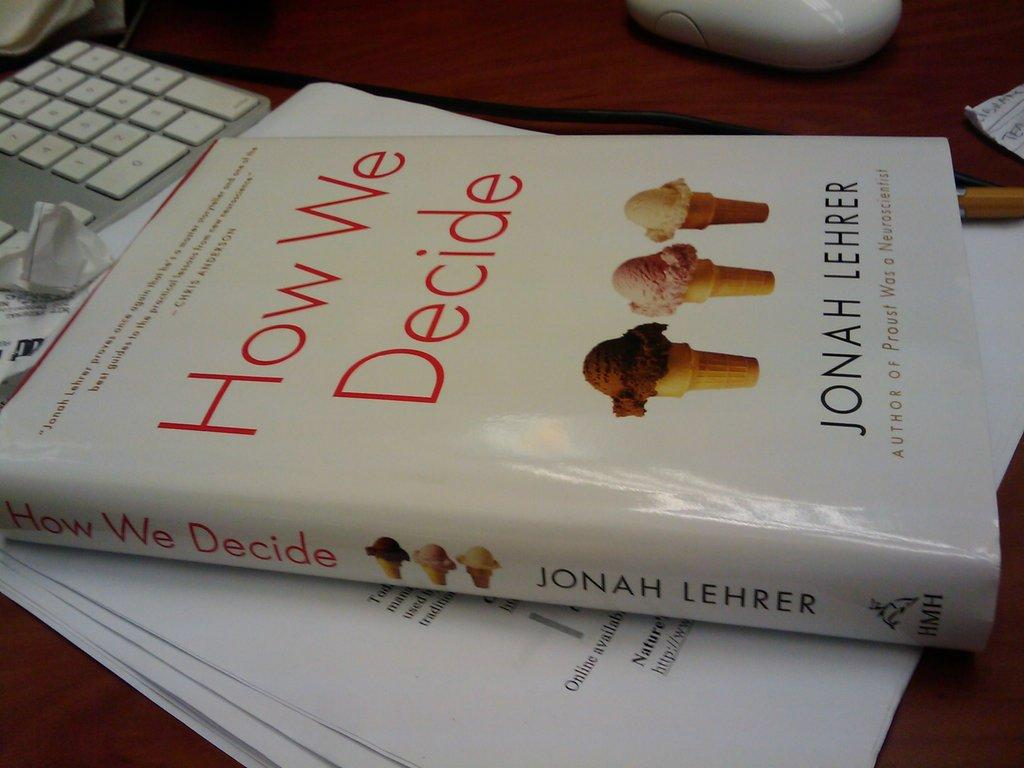<image>
Present a compact description of the photo's key features. A book on a stack of papers called How We Decide by Jonah Lehrer. 